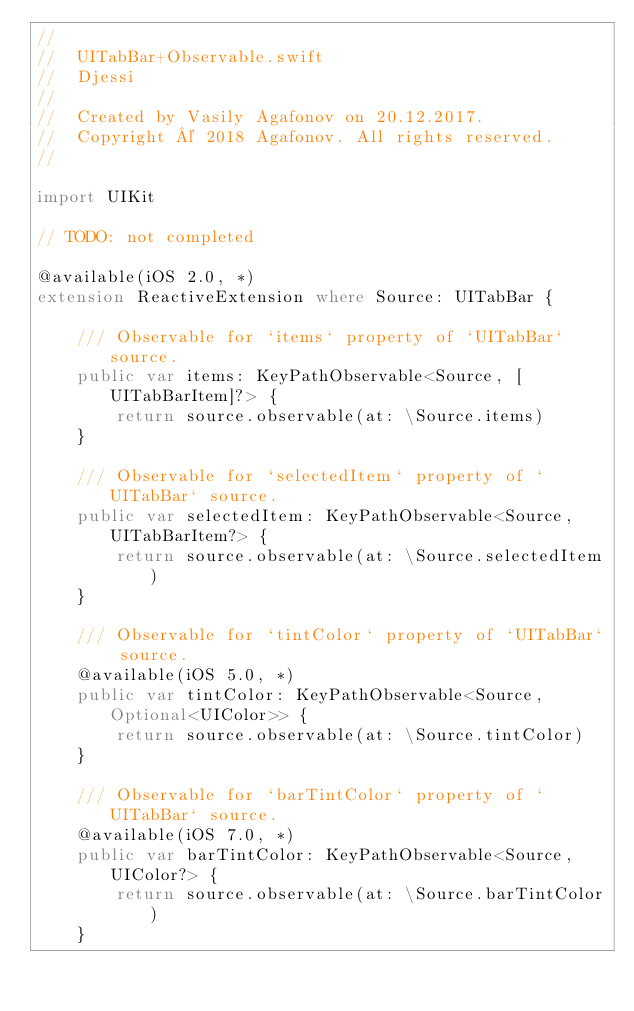<code> <loc_0><loc_0><loc_500><loc_500><_Swift_>//
//  UITabBar+Observable.swift
//  Djessi
//
//  Created by Vasily Agafonov on 20.12.2017.
//  Copyright © 2018 Agafonov. All rights reserved.
//

import UIKit

// TODO: not completed

@available(iOS 2.0, *)
extension ReactiveExtension where Source: UITabBar {
    
    /// Observable for `items` property of `UITabBar` source.
    public var items: KeyPathObservable<Source, [UITabBarItem]?> {
        return source.observable(at: \Source.items)
    }
    
    /// Observable for `selectedItem` property of `UITabBar` source.
    public var selectedItem: KeyPathObservable<Source, UITabBarItem?> {
        return source.observable(at: \Source.selectedItem)
    }
    
    /// Observable for `tintColor` property of `UITabBar` source.
    @available(iOS 5.0, *)
    public var tintColor: KeyPathObservable<Source, Optional<UIColor>> {
        return source.observable(at: \Source.tintColor)
    }
    
    /// Observable for `barTintColor` property of `UITabBar` source.
    @available(iOS 7.0, *)
    public var barTintColor: KeyPathObservable<Source, UIColor?> {
        return source.observable(at: \Source.barTintColor)
    }
    </code> 